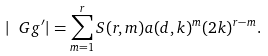Convert formula to latex. <formula><loc_0><loc_0><loc_500><loc_500>| \ G g ^ { \prime } | & = \sum _ { m = 1 } ^ { r } S ( r , m ) a ( d , k ) ^ { m } ( 2 k ) ^ { r - m } .</formula> 